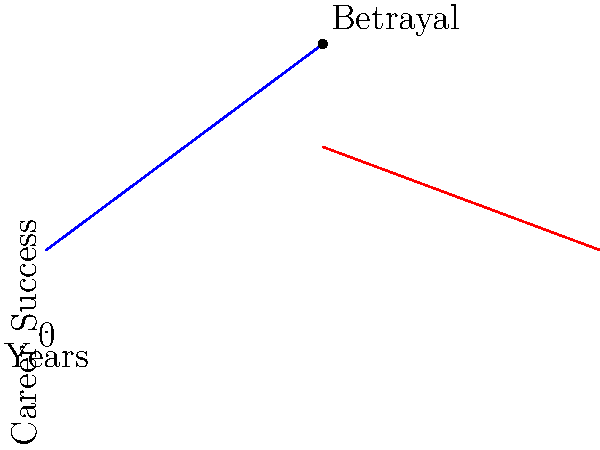Based on the graph showing career trajectory before and after a betrayal, what is the difference in slope between the pre-betrayal (blue) and post-betrayal (red) lines? To find the difference in slope between the pre-betrayal and post-betrayal lines:

1. Calculate the slope of the pre-betrayal (blue) line:
   The blue line rises from $y = 1$ at $x = 0$ to $y = 3.5$ at $x = 5$
   Slope = $\frac{\text{rise}}{\text{run}} = \frac{3.5 - 1}{5 - 0} = \frac{2.5}{5} = 0.5$

2. Calculate the slope of the post-betrayal (red) line:
   The red line falls from $y = 3.5$ at $x = 5$ to $y = 1$ at $x = 10$
   Slope = $\frac{\text{rise}}{\text{run}} = \frac{1 - 3.5}{10 - 5} = \frac{-2.5}{5} = -0.5$

3. Calculate the difference in slopes:
   Difference = Pre-betrayal slope - Post-betrayal slope
               = $0.5 - (-0.5) = 0.5 + 0.5 = 1$

Therefore, the difference in slope between the pre-betrayal and post-betrayal lines is 1.
Answer: 1 